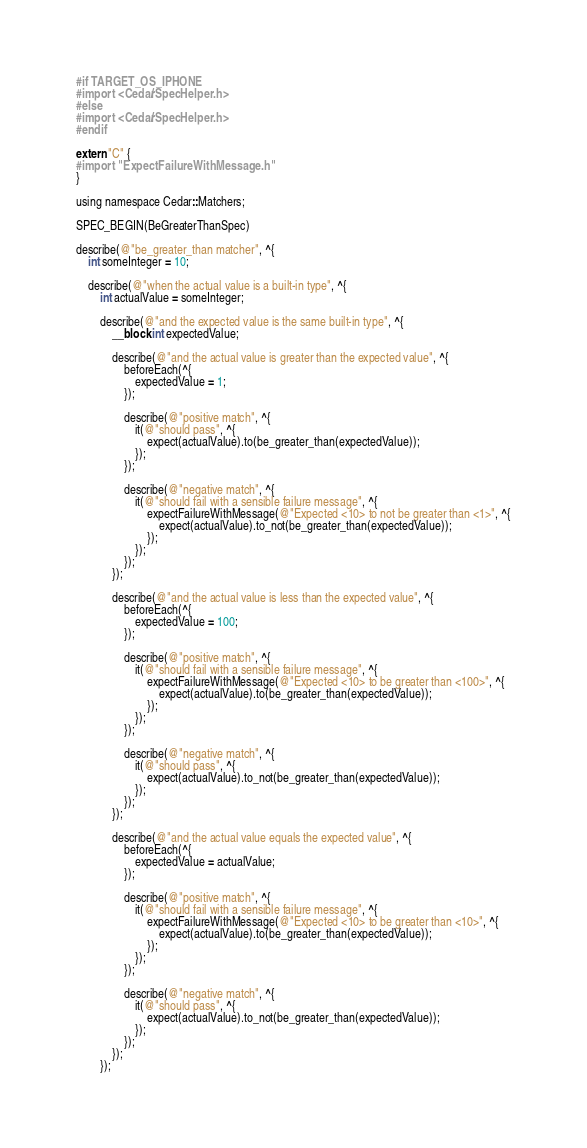<code> <loc_0><loc_0><loc_500><loc_500><_ObjectiveC_>#if TARGET_OS_IPHONE
#import <Cedar/SpecHelper.h>
#else
#import <Cedar/SpecHelper.h>
#endif

extern "C" {
#import "ExpectFailureWithMessage.h"
}

using namespace Cedar::Matchers;

SPEC_BEGIN(BeGreaterThanSpec)

describe(@"be_greater_than matcher", ^{
    int someInteger = 10;

    describe(@"when the actual value is a built-in type", ^{
        int actualValue = someInteger;

        describe(@"and the expected value is the same built-in type", ^{
            __block int expectedValue;

            describe(@"and the actual value is greater than the expected value", ^{
                beforeEach(^{
                    expectedValue = 1;
                });

                describe(@"positive match", ^{
                    it(@"should pass", ^{
                        expect(actualValue).to(be_greater_than(expectedValue));
                    });
                });

                describe(@"negative match", ^{
                    it(@"should fail with a sensible failure message", ^{
                        expectFailureWithMessage(@"Expected <10> to not be greater than <1>", ^{
                            expect(actualValue).to_not(be_greater_than(expectedValue));
                        });
                    });
                });
            });

            describe(@"and the actual value is less than the expected value", ^{
                beforeEach(^{
                    expectedValue = 100;
                });

                describe(@"positive match", ^{
                    it(@"should fail with a sensible failure message", ^{
                        expectFailureWithMessage(@"Expected <10> to be greater than <100>", ^{
                            expect(actualValue).to(be_greater_than(expectedValue));
                        });
                    });
                });

                describe(@"negative match", ^{
                    it(@"should pass", ^{
                        expect(actualValue).to_not(be_greater_than(expectedValue));
                    });
                });
            });

            describe(@"and the actual value equals the expected value", ^{
                beforeEach(^{
                    expectedValue = actualValue;
                });

                describe(@"positive match", ^{
                    it(@"should fail with a sensible failure message", ^{
                        expectFailureWithMessage(@"Expected <10> to be greater than <10>", ^{
                            expect(actualValue).to(be_greater_than(expectedValue));
                        });
                    });
                });

                describe(@"negative match", ^{
                    it(@"should pass", ^{
                        expect(actualValue).to_not(be_greater_than(expectedValue));
                    });
                });
            });
        });
</code> 